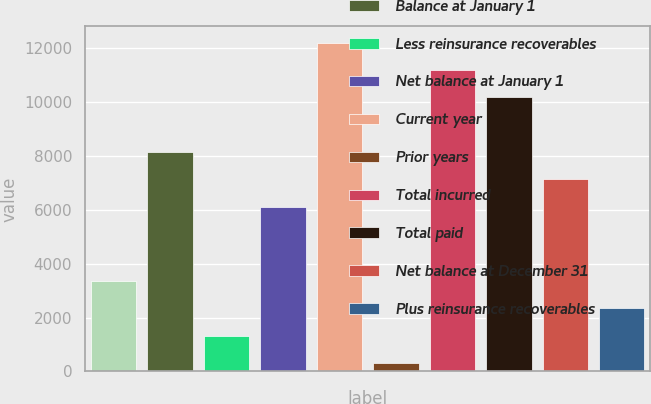Convert chart to OTSL. <chart><loc_0><loc_0><loc_500><loc_500><bar_chart><fcel>(millions)<fcel>Balance at January 1<fcel>Less reinsurance recoverables<fcel>Net balance at January 1<fcel>Current year<fcel>Prior years<fcel>Total incurred<fcel>Total paid<fcel>Net balance at December 31<fcel>Plus reinsurance recoverables<nl><fcel>3359.79<fcel>8149.86<fcel>1333.53<fcel>6123.6<fcel>12202.4<fcel>320.4<fcel>11189.2<fcel>10176.1<fcel>7136.73<fcel>2346.66<nl></chart> 